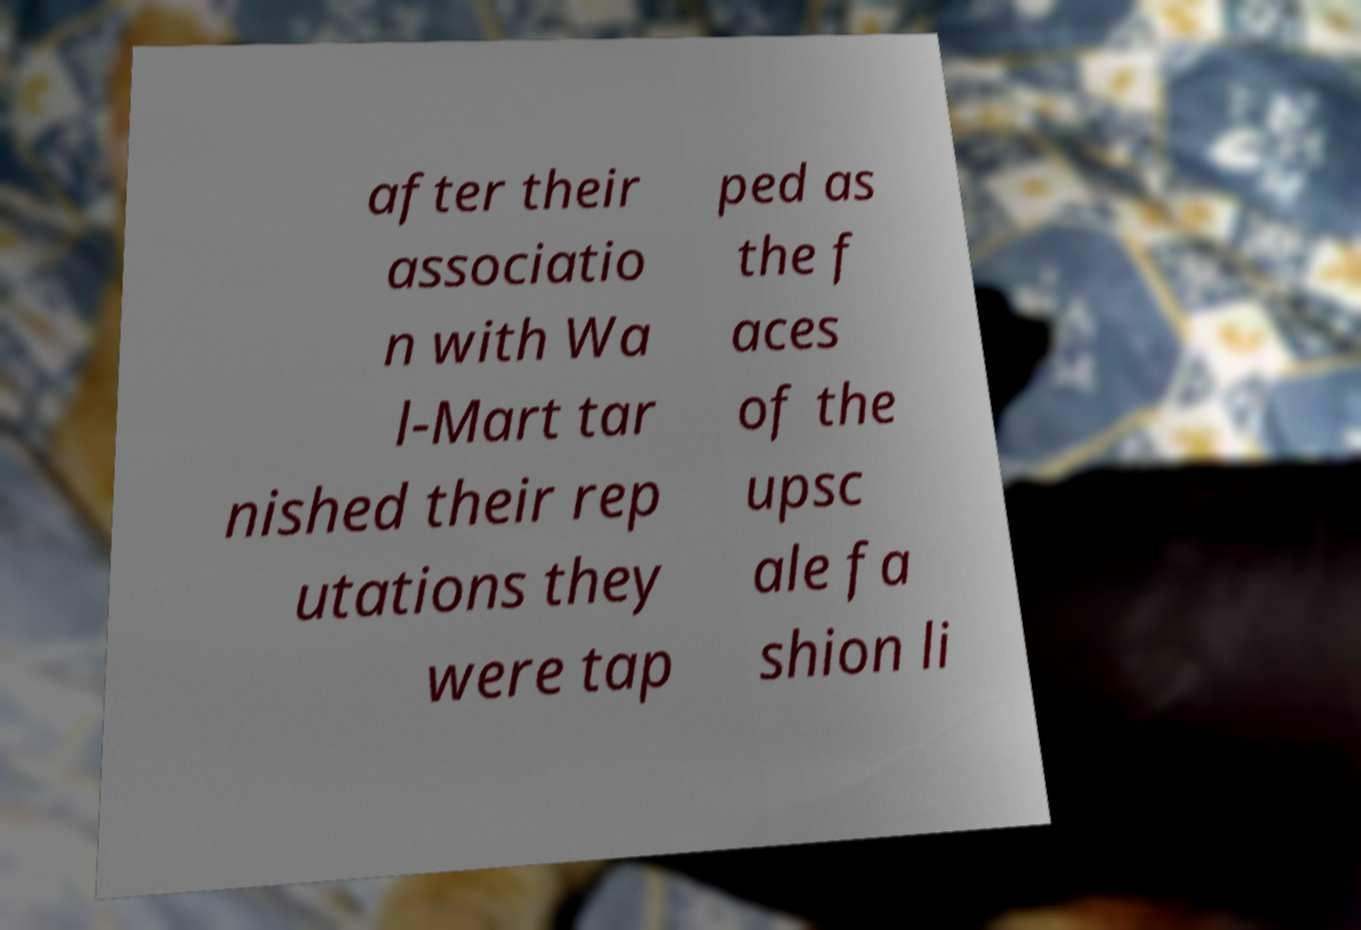I need the written content from this picture converted into text. Can you do that? after their associatio n with Wa l-Mart tar nished their rep utations they were tap ped as the f aces of the upsc ale fa shion li 